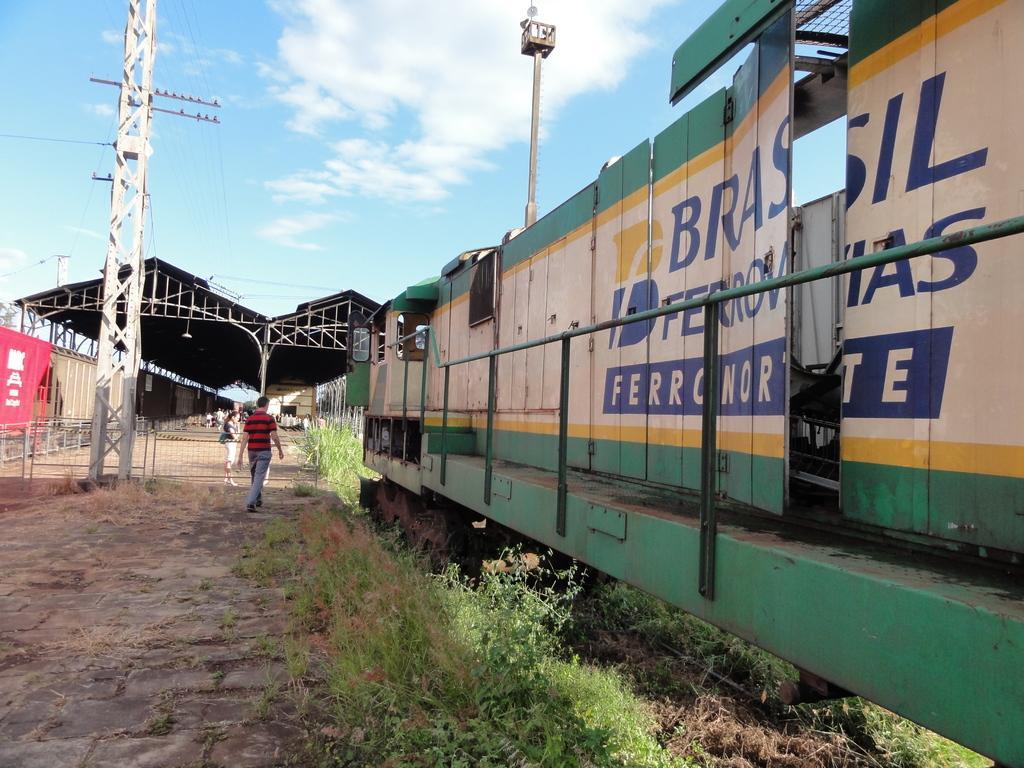Describe this image in one or two sentences. In the image we can see there are people walking and some of them are standing, they are wearing clothes. Here we can see a train, grass, footpath, tower, pole, electric wires and a cloudy pale blue sky. Here we can see a pole house and the fence. 